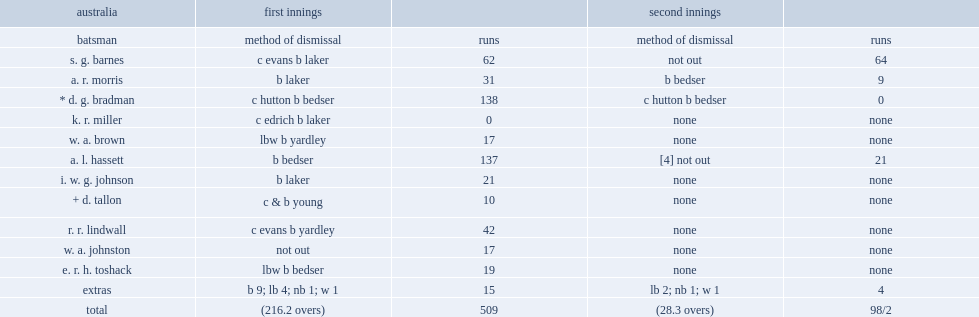How many runs did bradman get in first innings? 138.0. 